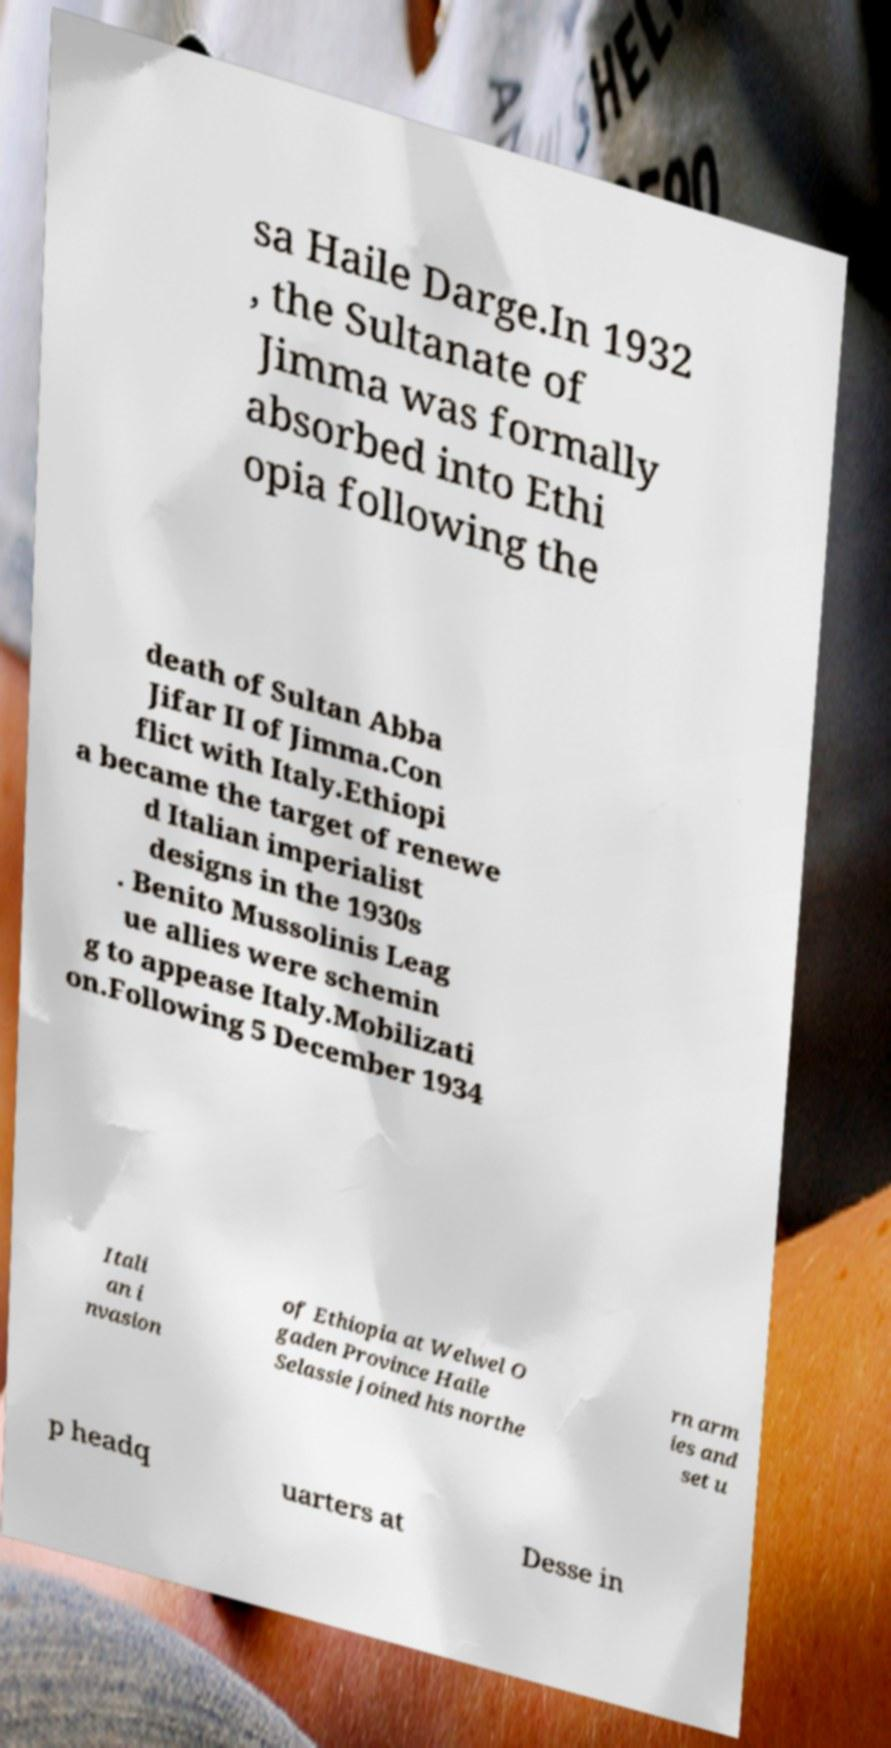I need the written content from this picture converted into text. Can you do that? sa Haile Darge.In 1932 , the Sultanate of Jimma was formally absorbed into Ethi opia following the death of Sultan Abba Jifar II of Jimma.Con flict with Italy.Ethiopi a became the target of renewe d Italian imperialist designs in the 1930s . Benito Mussolinis Leag ue allies were schemin g to appease Italy.Mobilizati on.Following 5 December 1934 Itali an i nvasion of Ethiopia at Welwel O gaden Province Haile Selassie joined his northe rn arm ies and set u p headq uarters at Desse in 